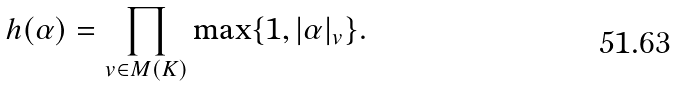Convert formula to latex. <formula><loc_0><loc_0><loc_500><loc_500>h ( \alpha ) = \prod _ { v \in M ( K ) } \max \{ 1 , | \alpha | _ { v } \} .</formula> 